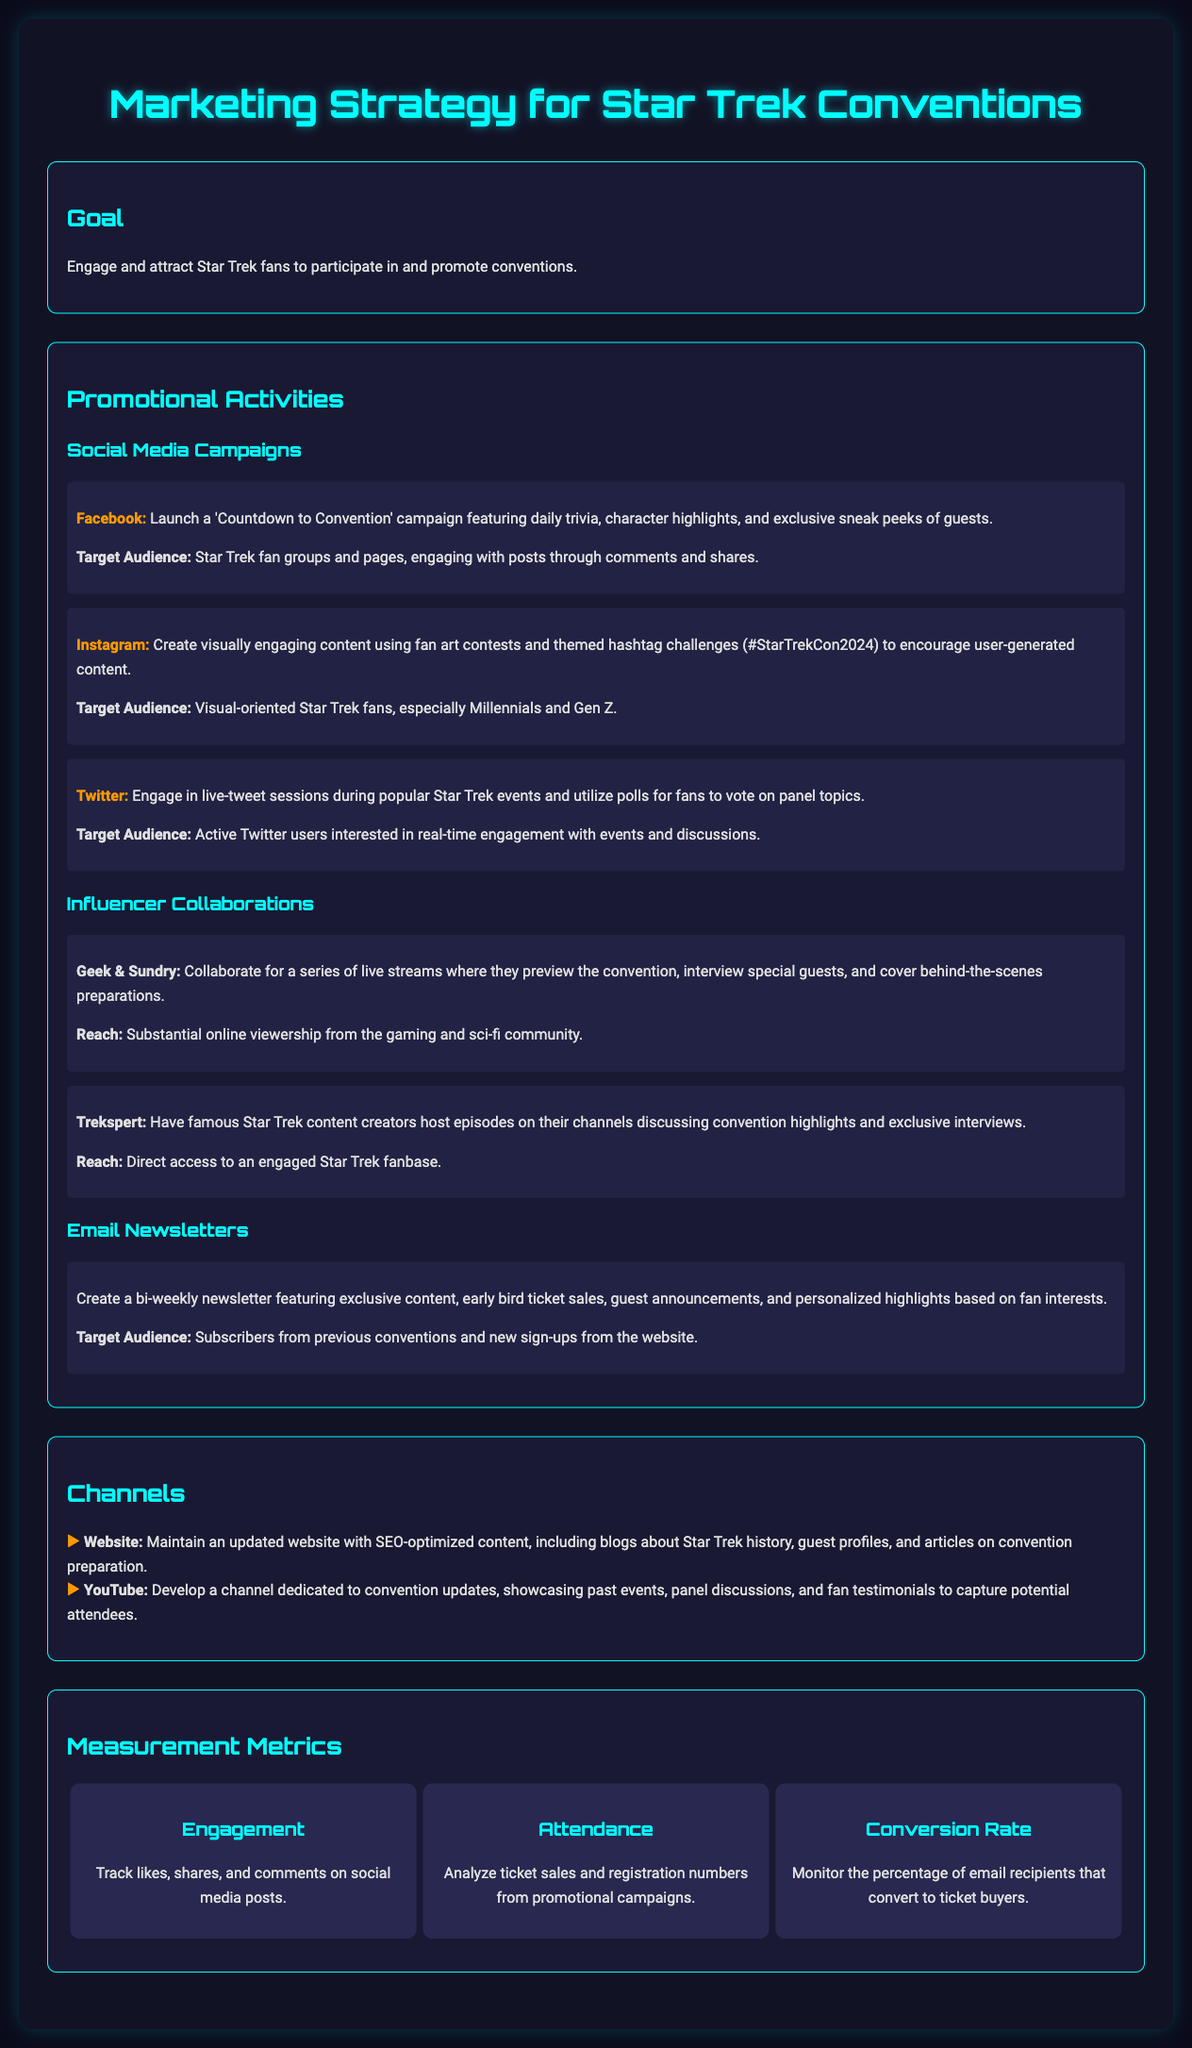What is the main goal of the marketing strategy? The main goal is to engage and attract Star Trek fans to participate in and promote conventions.
Answer: Engage and attract Star Trek fans Which social media platform is used for the 'Countdown to Convention' campaign? The 'Countdown to Convention' campaign is launched on Facebook.
Answer: Facebook What type of content will the bi-weekly newsletter feature? The bi-weekly newsletter will feature exclusive content, early bird ticket sales, guest announcements, and personalized highlights.
Answer: Exclusive content, early bird ticket sales, guest announcements, and personalized highlights Who are the collaborators mentioned for influencer promotions? The collaborators mentioned are Geek & Sundry and Trekspert.
Answer: Geek & Sundry and Trekspert What is the target audience for the Instagram campaign? The target audience for the Instagram campaign is visual-oriented Star Trek fans, especially Millennials and Gen Z.
Answer: Visual-oriented Star Trek fans, especially Millennials and Gen Z How often will the email newsletters be sent out? The email newsletters will be sent out bi-weekly.
Answer: Bi-weekly What type of updates will the YouTube channel provide? The YouTube channel will provide convention updates, showcasing past events, panel discussions, and fan testimonials.
Answer: Convention updates, showcasing past events, panel discussions, and fan testimonials What metrics are used to measure engagement? Engagement is tracked by likes, shares, and comments on social media posts.
Answer: Likes, shares, and comments What is one of the proposed activities for Twitter engagement? One proposed activity is to engage in live-tweet sessions during popular Star Trek events.
Answer: Live-tweet sessions during popular Star Trek events 